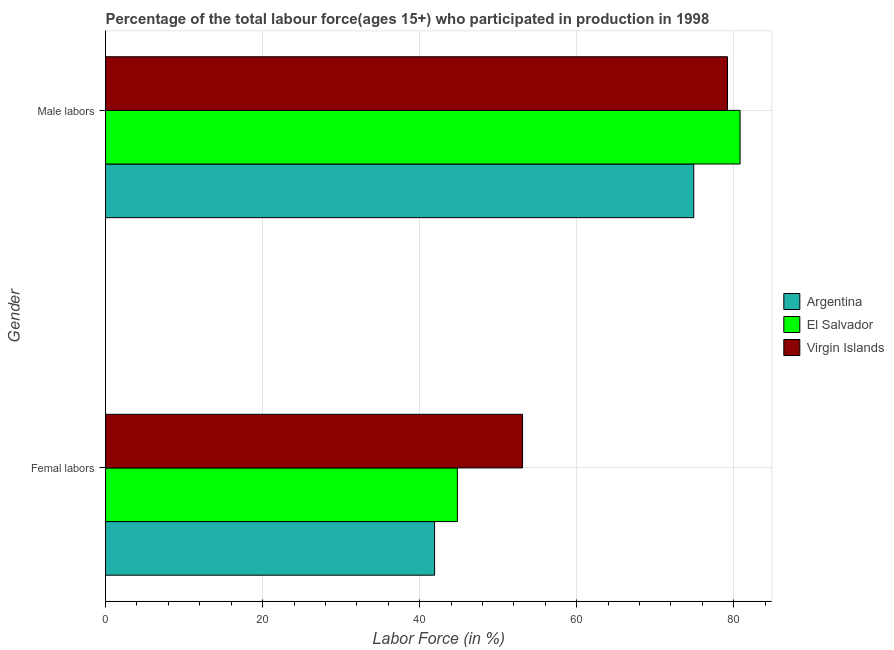How many different coloured bars are there?
Keep it short and to the point. 3. Are the number of bars per tick equal to the number of legend labels?
Your answer should be very brief. Yes. Are the number of bars on each tick of the Y-axis equal?
Give a very brief answer. Yes. How many bars are there on the 2nd tick from the top?
Offer a terse response. 3. What is the label of the 2nd group of bars from the top?
Give a very brief answer. Femal labors. What is the percentage of male labour force in Virgin Islands?
Keep it short and to the point. 79.2. Across all countries, what is the maximum percentage of female labor force?
Ensure brevity in your answer.  53.1. Across all countries, what is the minimum percentage of male labour force?
Ensure brevity in your answer.  74.9. In which country was the percentage of female labor force maximum?
Your answer should be very brief. Virgin Islands. In which country was the percentage of female labor force minimum?
Keep it short and to the point. Argentina. What is the total percentage of male labour force in the graph?
Provide a short and direct response. 234.9. What is the difference between the percentage of male labour force in Argentina and that in Virgin Islands?
Provide a short and direct response. -4.3. What is the difference between the percentage of male labour force in Argentina and the percentage of female labor force in El Salvador?
Offer a very short reply. 30.1. What is the average percentage of male labour force per country?
Your answer should be very brief. 78.3. What is the difference between the percentage of male labour force and percentage of female labor force in Virgin Islands?
Your answer should be very brief. 26.1. In how many countries, is the percentage of female labor force greater than 52 %?
Keep it short and to the point. 1. What is the ratio of the percentage of male labour force in El Salvador to that in Virgin Islands?
Make the answer very short. 1.02. Is the percentage of male labour force in Argentina less than that in El Salvador?
Your answer should be compact. Yes. In how many countries, is the percentage of female labor force greater than the average percentage of female labor force taken over all countries?
Your answer should be compact. 1. What does the 3rd bar from the bottom in Male labors represents?
Offer a very short reply. Virgin Islands. How many bars are there?
Your answer should be compact. 6. Are all the bars in the graph horizontal?
Ensure brevity in your answer.  Yes. Are the values on the major ticks of X-axis written in scientific E-notation?
Your answer should be compact. No. Does the graph contain any zero values?
Provide a succinct answer. No. Where does the legend appear in the graph?
Offer a terse response. Center right. What is the title of the graph?
Your answer should be compact. Percentage of the total labour force(ages 15+) who participated in production in 1998. What is the label or title of the X-axis?
Offer a very short reply. Labor Force (in %). What is the label or title of the Y-axis?
Offer a very short reply. Gender. What is the Labor Force (in %) of Argentina in Femal labors?
Your response must be concise. 41.9. What is the Labor Force (in %) in El Salvador in Femal labors?
Provide a short and direct response. 44.8. What is the Labor Force (in %) in Virgin Islands in Femal labors?
Your answer should be very brief. 53.1. What is the Labor Force (in %) of Argentina in Male labors?
Make the answer very short. 74.9. What is the Labor Force (in %) in El Salvador in Male labors?
Provide a succinct answer. 80.8. What is the Labor Force (in %) of Virgin Islands in Male labors?
Provide a succinct answer. 79.2. Across all Gender, what is the maximum Labor Force (in %) in Argentina?
Make the answer very short. 74.9. Across all Gender, what is the maximum Labor Force (in %) in El Salvador?
Make the answer very short. 80.8. Across all Gender, what is the maximum Labor Force (in %) in Virgin Islands?
Give a very brief answer. 79.2. Across all Gender, what is the minimum Labor Force (in %) of Argentina?
Offer a very short reply. 41.9. Across all Gender, what is the minimum Labor Force (in %) in El Salvador?
Your answer should be compact. 44.8. Across all Gender, what is the minimum Labor Force (in %) of Virgin Islands?
Keep it short and to the point. 53.1. What is the total Labor Force (in %) in Argentina in the graph?
Offer a very short reply. 116.8. What is the total Labor Force (in %) of El Salvador in the graph?
Provide a succinct answer. 125.6. What is the total Labor Force (in %) of Virgin Islands in the graph?
Your answer should be very brief. 132.3. What is the difference between the Labor Force (in %) of Argentina in Femal labors and that in Male labors?
Keep it short and to the point. -33. What is the difference between the Labor Force (in %) in El Salvador in Femal labors and that in Male labors?
Ensure brevity in your answer.  -36. What is the difference between the Labor Force (in %) in Virgin Islands in Femal labors and that in Male labors?
Keep it short and to the point. -26.1. What is the difference between the Labor Force (in %) of Argentina in Femal labors and the Labor Force (in %) of El Salvador in Male labors?
Your answer should be very brief. -38.9. What is the difference between the Labor Force (in %) in Argentina in Femal labors and the Labor Force (in %) in Virgin Islands in Male labors?
Offer a very short reply. -37.3. What is the difference between the Labor Force (in %) in El Salvador in Femal labors and the Labor Force (in %) in Virgin Islands in Male labors?
Give a very brief answer. -34.4. What is the average Labor Force (in %) in Argentina per Gender?
Your response must be concise. 58.4. What is the average Labor Force (in %) of El Salvador per Gender?
Your answer should be compact. 62.8. What is the average Labor Force (in %) of Virgin Islands per Gender?
Your answer should be compact. 66.15. What is the difference between the Labor Force (in %) of Argentina and Labor Force (in %) of Virgin Islands in Femal labors?
Offer a terse response. -11.2. What is the ratio of the Labor Force (in %) of Argentina in Femal labors to that in Male labors?
Offer a very short reply. 0.56. What is the ratio of the Labor Force (in %) in El Salvador in Femal labors to that in Male labors?
Offer a terse response. 0.55. What is the ratio of the Labor Force (in %) of Virgin Islands in Femal labors to that in Male labors?
Ensure brevity in your answer.  0.67. What is the difference between the highest and the second highest Labor Force (in %) in El Salvador?
Keep it short and to the point. 36. What is the difference between the highest and the second highest Labor Force (in %) in Virgin Islands?
Keep it short and to the point. 26.1. What is the difference between the highest and the lowest Labor Force (in %) of Argentina?
Offer a very short reply. 33. What is the difference between the highest and the lowest Labor Force (in %) of El Salvador?
Your response must be concise. 36. What is the difference between the highest and the lowest Labor Force (in %) of Virgin Islands?
Your answer should be compact. 26.1. 